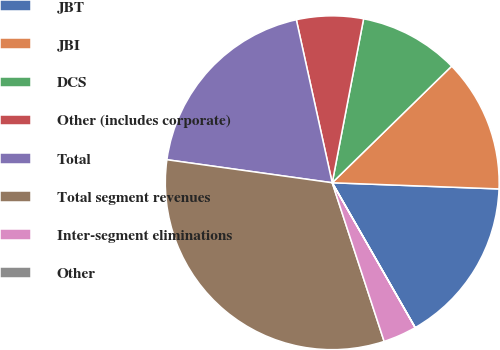Convert chart. <chart><loc_0><loc_0><loc_500><loc_500><pie_chart><fcel>JBT<fcel>JBI<fcel>DCS<fcel>Other (includes corporate)<fcel>Total<fcel>Total segment revenues<fcel>Inter-segment eliminations<fcel>Other<nl><fcel>16.13%<fcel>12.9%<fcel>9.68%<fcel>6.46%<fcel>19.35%<fcel>32.24%<fcel>3.24%<fcel>0.01%<nl></chart> 